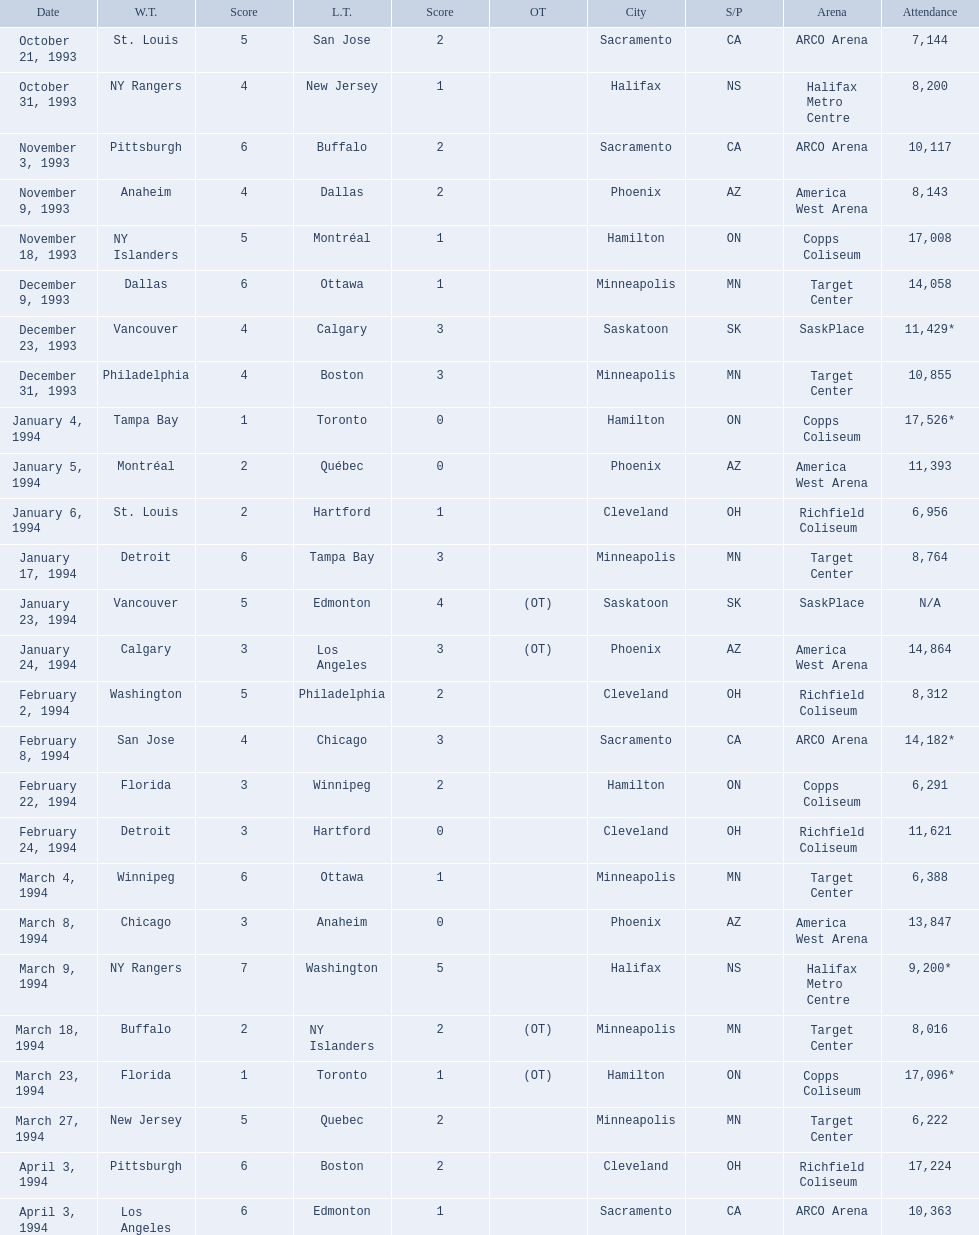Which dates saw the winning team score only one point? January 4, 1994, March 23, 1994. Of these two, which date had higher attendance? January 4, 1994. 